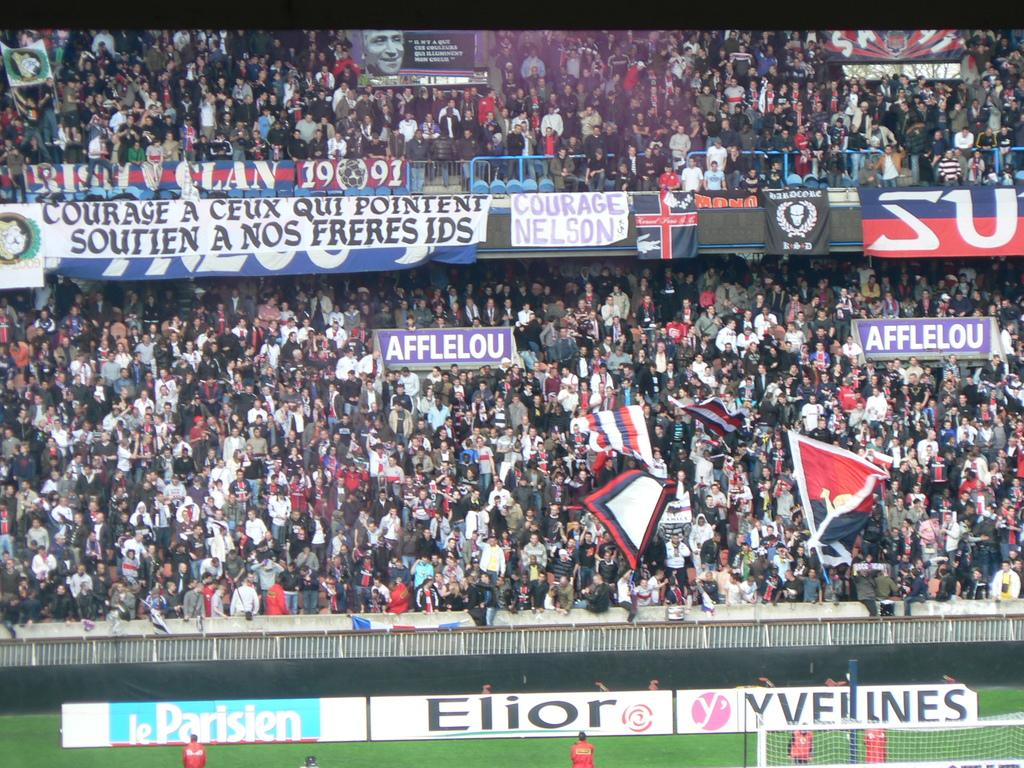<image>
Relay a brief, clear account of the picture shown. One of the adverts on the pitch is for le Parisien. 